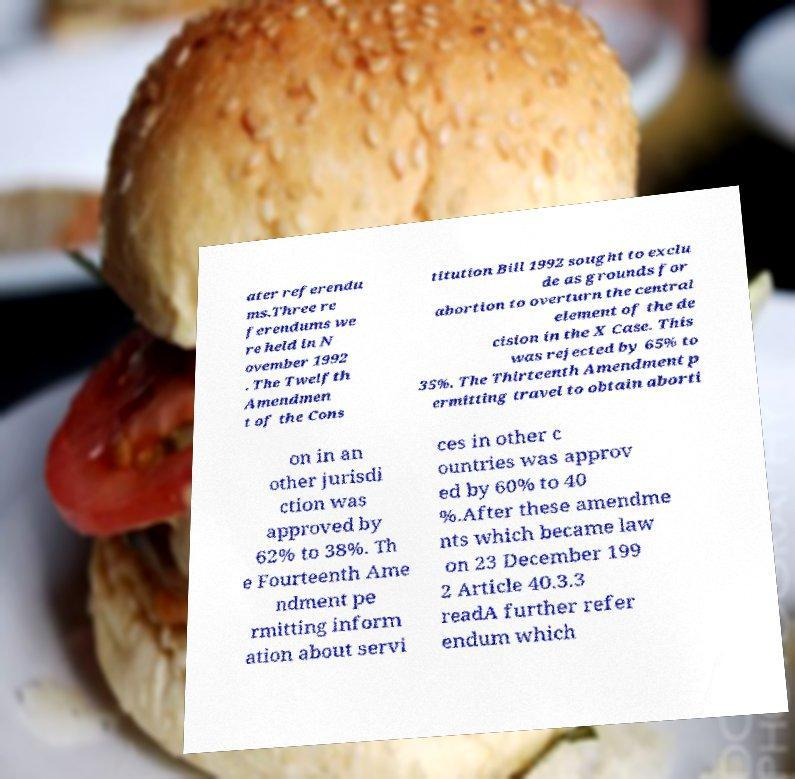There's text embedded in this image that I need extracted. Can you transcribe it verbatim? ater referendu ms.Three re ferendums we re held in N ovember 1992 . The Twelfth Amendmen t of the Cons titution Bill 1992 sought to exclu de as grounds for abortion to overturn the central element of the de cision in the X Case. This was rejected by 65% to 35%. The Thirteenth Amendment p ermitting travel to obtain aborti on in an other jurisdi ction was approved by 62% to 38%. Th e Fourteenth Ame ndment pe rmitting inform ation about servi ces in other c ountries was approv ed by 60% to 40 %.After these amendme nts which became law on 23 December 199 2 Article 40.3.3 readA further refer endum which 